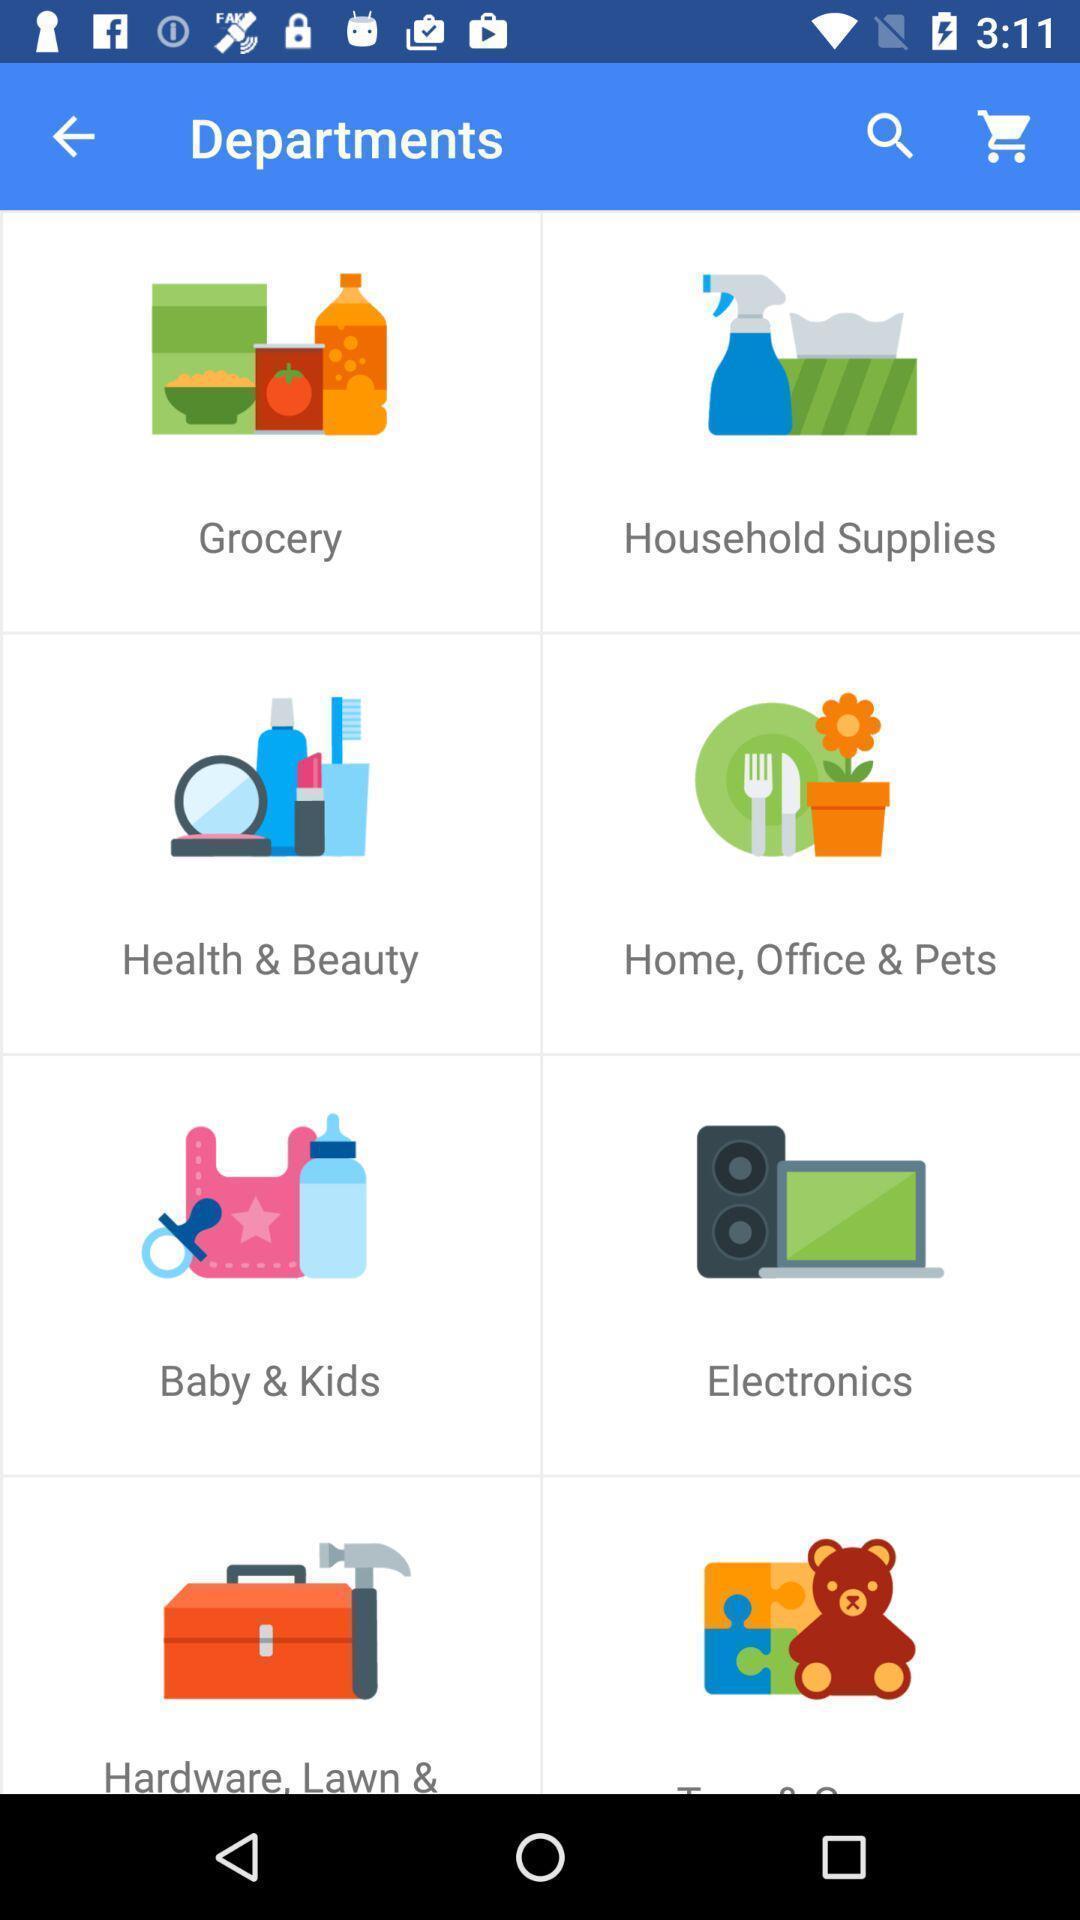Give me a narrative description of this picture. Various tools in a departments page of a shopping app. 